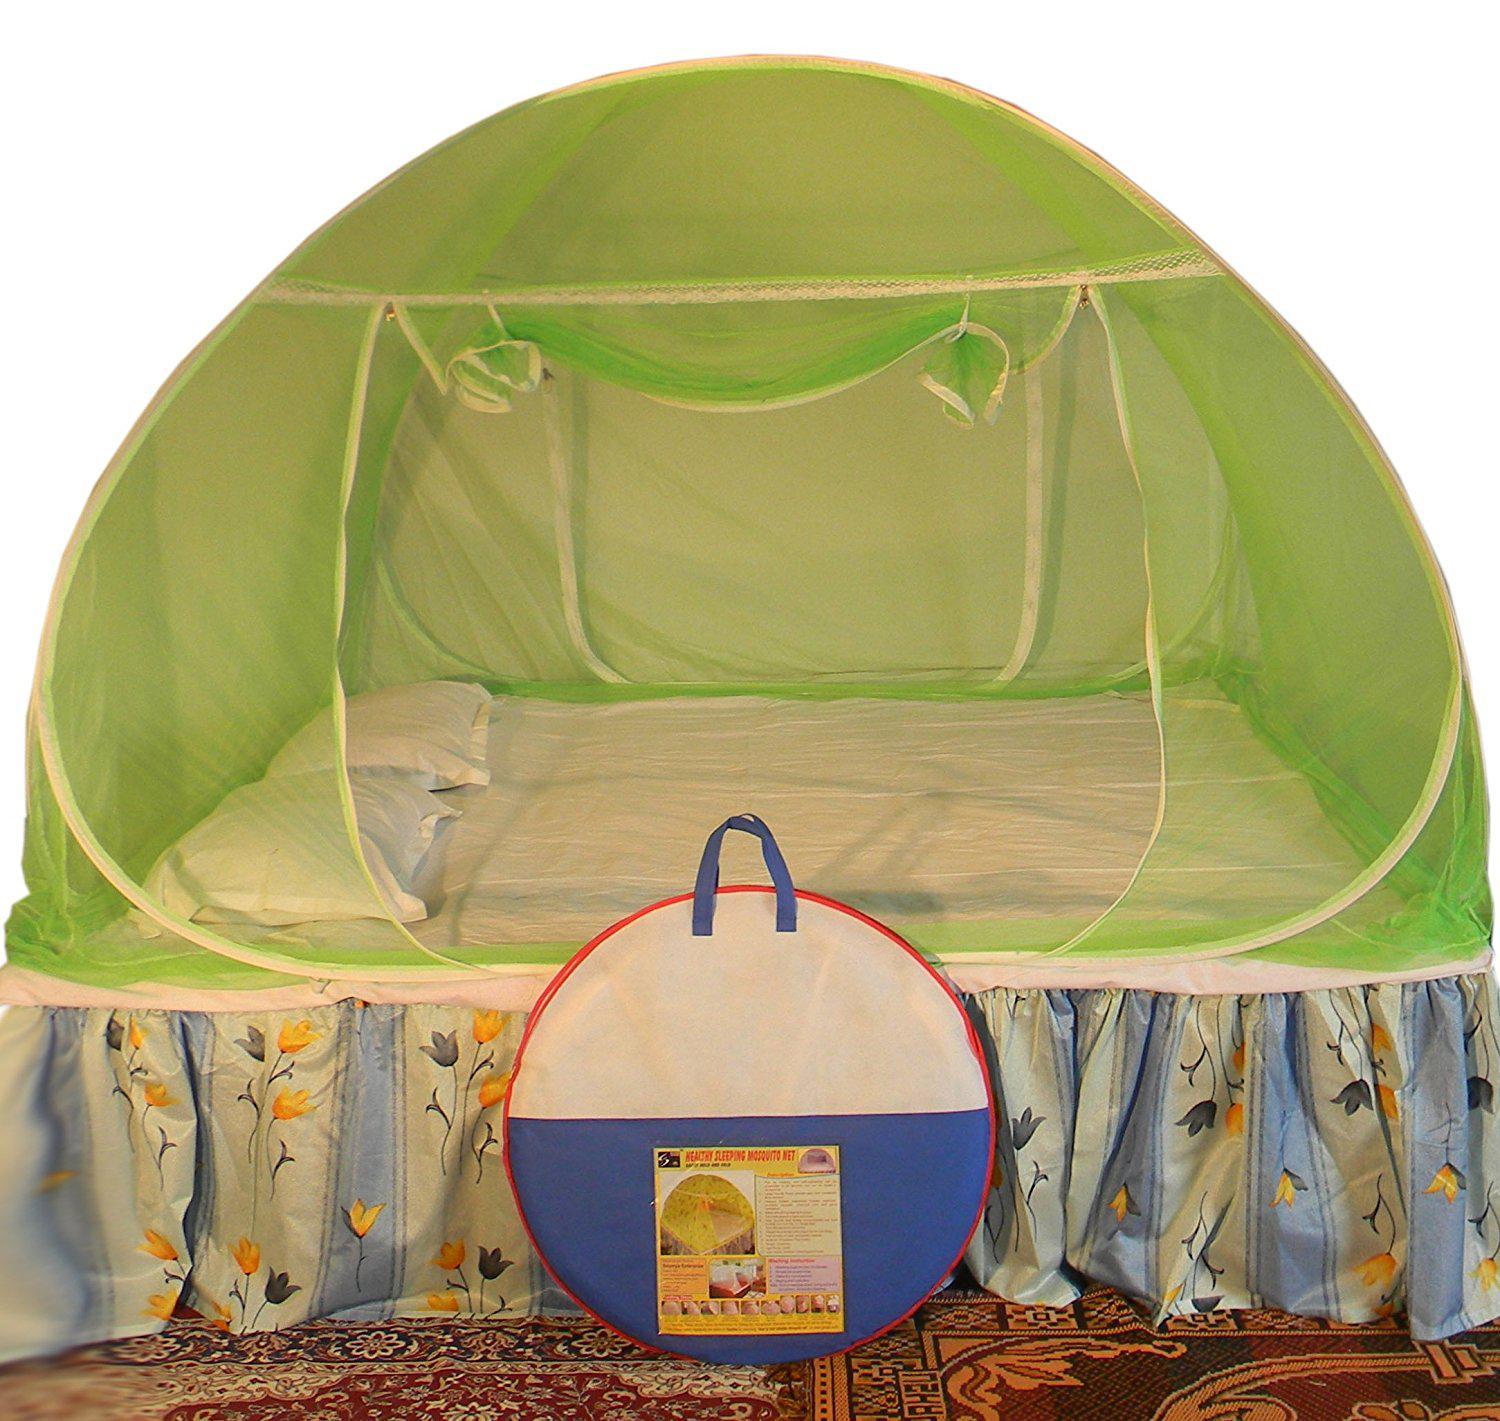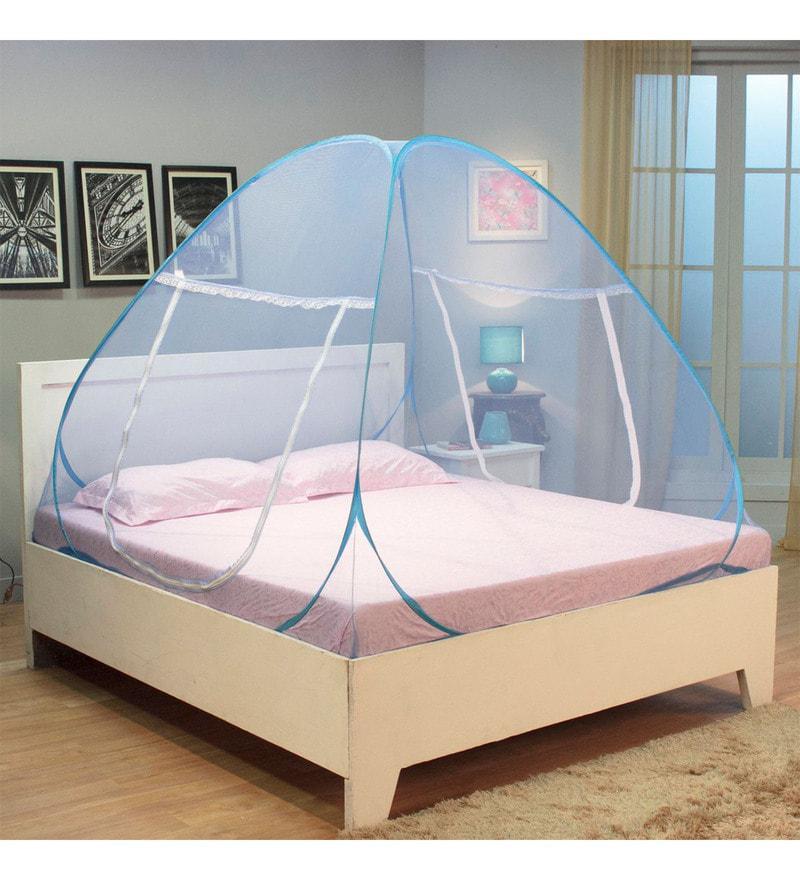The first image is the image on the left, the second image is the image on the right. Considering the images on both sides, is "Both beds have headboards." valid? Answer yes or no. No. 